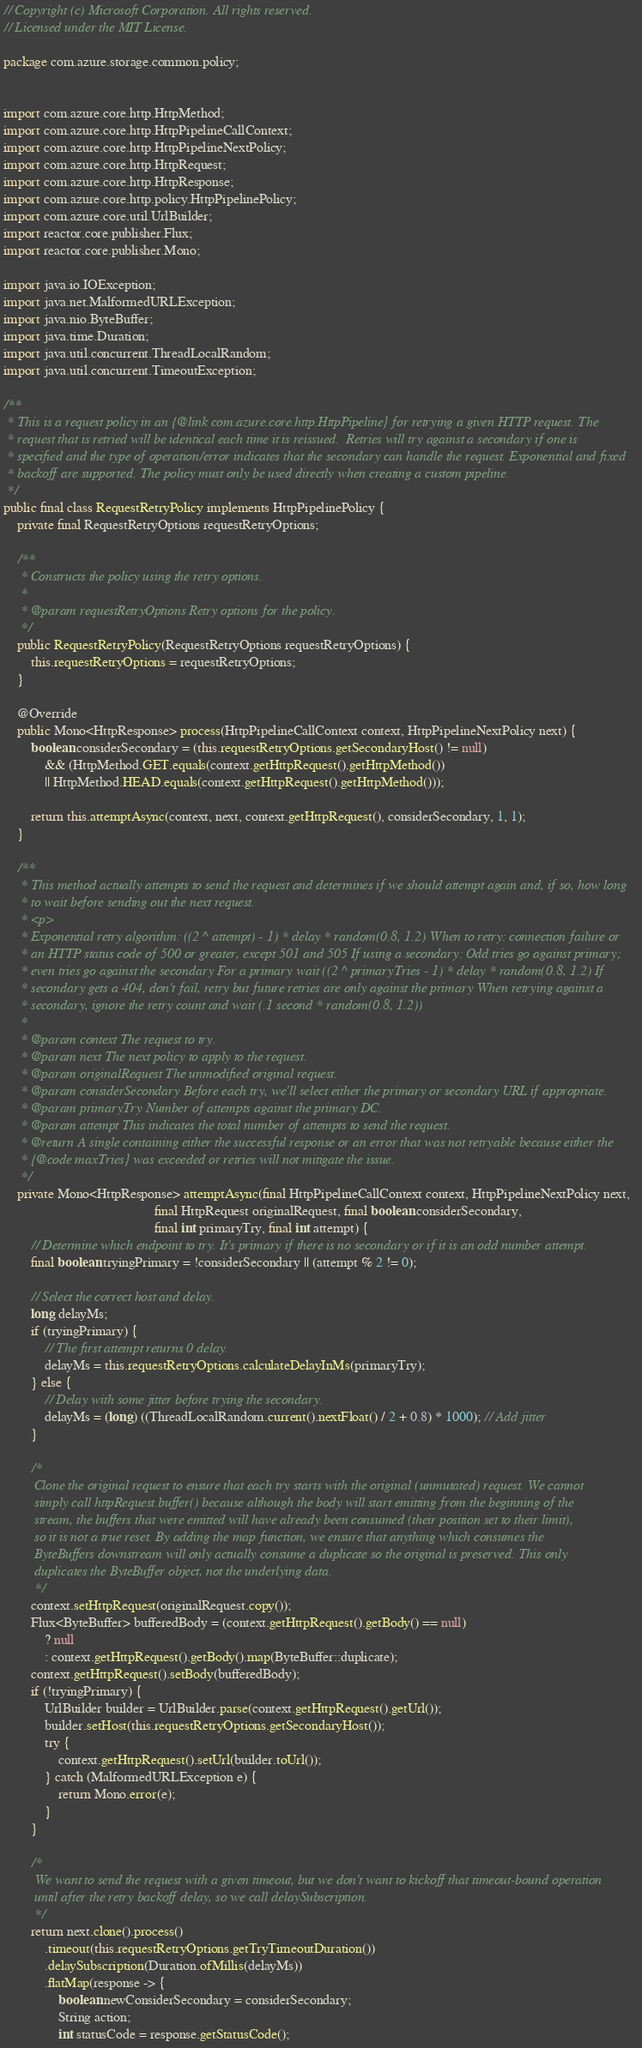Convert code to text. <code><loc_0><loc_0><loc_500><loc_500><_Java_>// Copyright (c) Microsoft Corporation. All rights reserved.
// Licensed under the MIT License.

package com.azure.storage.common.policy;


import com.azure.core.http.HttpMethod;
import com.azure.core.http.HttpPipelineCallContext;
import com.azure.core.http.HttpPipelineNextPolicy;
import com.azure.core.http.HttpRequest;
import com.azure.core.http.HttpResponse;
import com.azure.core.http.policy.HttpPipelinePolicy;
import com.azure.core.util.UrlBuilder;
import reactor.core.publisher.Flux;
import reactor.core.publisher.Mono;

import java.io.IOException;
import java.net.MalformedURLException;
import java.nio.ByteBuffer;
import java.time.Duration;
import java.util.concurrent.ThreadLocalRandom;
import java.util.concurrent.TimeoutException;

/**
 * This is a request policy in an {@link com.azure.core.http.HttpPipeline} for retrying a given HTTP request. The
 * request that is retried will be identical each time it is reissued.  Retries will try against a secondary if one is
 * specified and the type of operation/error indicates that the secondary can handle the request. Exponential and fixed
 * backoff are supported. The policy must only be used directly when creating a custom pipeline.
 */
public final class RequestRetryPolicy implements HttpPipelinePolicy {
    private final RequestRetryOptions requestRetryOptions;

    /**
     * Constructs the policy using the retry options.
     *
     * @param requestRetryOptions Retry options for the policy.
     */
    public RequestRetryPolicy(RequestRetryOptions requestRetryOptions) {
        this.requestRetryOptions = requestRetryOptions;
    }

    @Override
    public Mono<HttpResponse> process(HttpPipelineCallContext context, HttpPipelineNextPolicy next) {
        boolean considerSecondary = (this.requestRetryOptions.getSecondaryHost() != null)
            && (HttpMethod.GET.equals(context.getHttpRequest().getHttpMethod())
            || HttpMethod.HEAD.equals(context.getHttpRequest().getHttpMethod()));

        return this.attemptAsync(context, next, context.getHttpRequest(), considerSecondary, 1, 1);
    }

    /**
     * This method actually attempts to send the request and determines if we should attempt again and, if so, how long
     * to wait before sending out the next request.
     * <p>
     * Exponential retry algorithm: ((2 ^ attempt) - 1) * delay * random(0.8, 1.2) When to retry: connection failure or
     * an HTTP status code of 500 or greater, except 501 and 505 If using a secondary: Odd tries go against primary;
     * even tries go against the secondary For a primary wait ((2 ^ primaryTries - 1) * delay * random(0.8, 1.2) If
     * secondary gets a 404, don't fail, retry but future retries are only against the primary When retrying against a
     * secondary, ignore the retry count and wait (.1 second * random(0.8, 1.2))
     *
     * @param context The request to try.
     * @param next The next policy to apply to the request.
     * @param originalRequest The unmodified original request.
     * @param considerSecondary Before each try, we'll select either the primary or secondary URL if appropriate.
     * @param primaryTry Number of attempts against the primary DC.
     * @param attempt This indicates the total number of attempts to send the request.
     * @return A single containing either the successful response or an error that was not retryable because either the
     * {@code maxTries} was exceeded or retries will not mitigate the issue.
     */
    private Mono<HttpResponse> attemptAsync(final HttpPipelineCallContext context, HttpPipelineNextPolicy next,
                                            final HttpRequest originalRequest, final boolean considerSecondary,
                                            final int primaryTry, final int attempt) {
        // Determine which endpoint to try. It's primary if there is no secondary or if it is an odd number attempt.
        final boolean tryingPrimary = !considerSecondary || (attempt % 2 != 0);

        // Select the correct host and delay.
        long delayMs;
        if (tryingPrimary) {
            // The first attempt returns 0 delay.
            delayMs = this.requestRetryOptions.calculateDelayInMs(primaryTry);
        } else {
            // Delay with some jitter before trying the secondary.
            delayMs = (long) ((ThreadLocalRandom.current().nextFloat() / 2 + 0.8) * 1000); // Add jitter
        }

        /*
         Clone the original request to ensure that each try starts with the original (unmutated) request. We cannot
         simply call httpRequest.buffer() because although the body will start emitting from the beginning of the
         stream, the buffers that were emitted will have already been consumed (their position set to their limit),
         so it is not a true reset. By adding the map function, we ensure that anything which consumes the
         ByteBuffers downstream will only actually consume a duplicate so the original is preserved. This only
         duplicates the ByteBuffer object, not the underlying data.
         */
        context.setHttpRequest(originalRequest.copy());
        Flux<ByteBuffer> bufferedBody = (context.getHttpRequest().getBody() == null)
            ? null
            : context.getHttpRequest().getBody().map(ByteBuffer::duplicate);
        context.getHttpRequest().setBody(bufferedBody);
        if (!tryingPrimary) {
            UrlBuilder builder = UrlBuilder.parse(context.getHttpRequest().getUrl());
            builder.setHost(this.requestRetryOptions.getSecondaryHost());
            try {
                context.getHttpRequest().setUrl(builder.toUrl());
            } catch (MalformedURLException e) {
                return Mono.error(e);
            }
        }

        /*
         We want to send the request with a given timeout, but we don't want to kickoff that timeout-bound operation
         until after the retry backoff delay, so we call delaySubscription.
         */
        return next.clone().process()
            .timeout(this.requestRetryOptions.getTryTimeoutDuration())
            .delaySubscription(Duration.ofMillis(delayMs))
            .flatMap(response -> {
                boolean newConsiderSecondary = considerSecondary;
                String action;
                int statusCode = response.getStatusCode();
</code> 